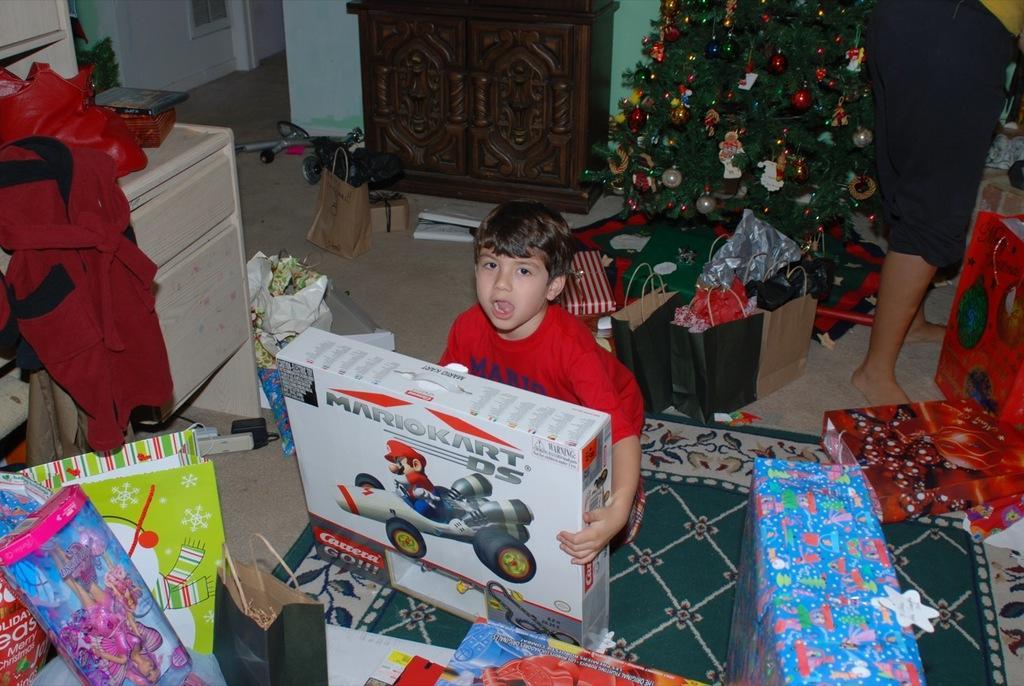Could you give a brief overview of what you see in this image? In this image I can see a person sitting holding a cardboard box. The person is wearing red color shirt, background I can see few cupboards in cream color, a Christmas tree in green color. I can also see the other person standing wearing black color pant and wall is in green color. 